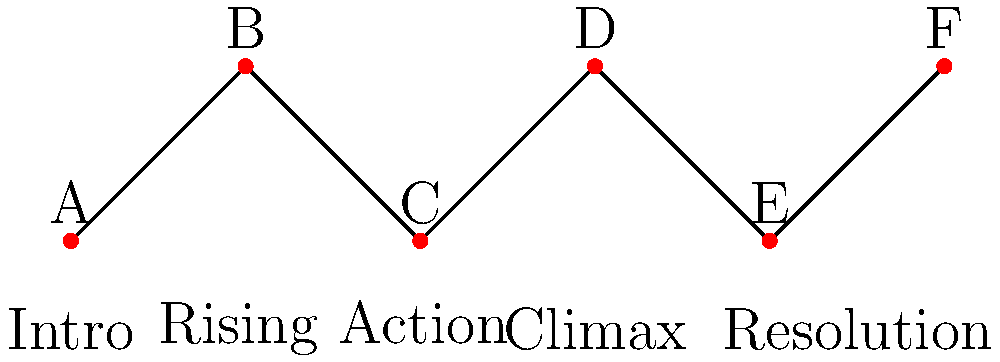In this topological graph representing the story arc of a political thriller, which node likely represents the major plot twist that changes the course of the narrative? To identify the major plot twist in this topological representation of a political thriller's story arc, let's analyze the graph step-by-step:

1. The graph shows six nodes (A, B, C, D, E, F) connected in a linear fashion, representing the progression of the story.

2. The vertical positioning of the nodes indicates the intensity or complexity of the plot at each point:
   - Nodes A, C, and E are at a lower level
   - Nodes B, D, and F are at a higher level

3. The labels below the graph provide context for the story structure:
   - "Intro" is near the beginning (Node A)
   - "Rising Action" is in the middle (between Nodes B and C)
   - "Climax" is towards the end (near Node D)
   - "Resolution" is at the end (between Nodes E and F)

4. In a typical thriller structure, the major plot twist often occurs just before or at the climax of the story.

5. Node D is positioned at the highest point of the graph and aligns with the "Climax" label.

6. The significant upward shift from Node C to Node D suggests a dramatic change in the story's direction or intensity.

Given these observations, Node D is the most likely representation of the major plot twist. It marks the point where the story reaches its highest intensity, typically where the protagonist faces the greatest challenge or a shocking revelation occurs, fundamentally altering the course of the narrative.
Answer: Node D 